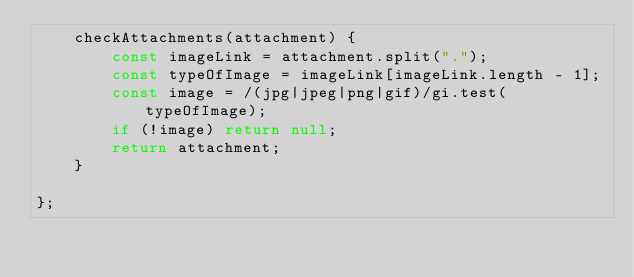<code> <loc_0><loc_0><loc_500><loc_500><_JavaScript_>    checkAttachments(attachment) {
        const imageLink = attachment.split(".");
        const typeOfImage = imageLink[imageLink.length - 1];
        const image = /(jpg|jpeg|png|gif)/gi.test(typeOfImage);
        if (!image) return null;
        return attachment;
    }

};
</code> 